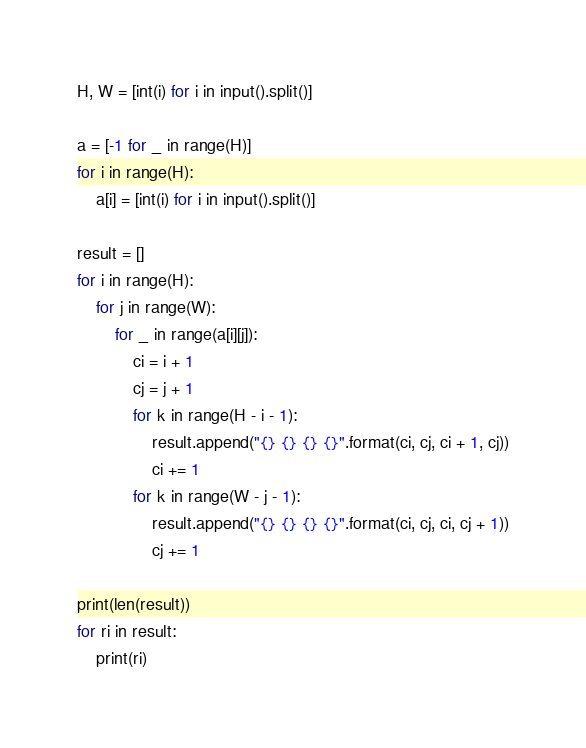<code> <loc_0><loc_0><loc_500><loc_500><_Python_>H, W = [int(i) for i in input().split()]

a = [-1 for _ in range(H)]
for i in range(H):
    a[i] = [int(i) for i in input().split()]

result = []
for i in range(H):
    for j in range(W):
        for _ in range(a[i][j]):
            ci = i + 1
            cj = j + 1
            for k in range(H - i - 1):
                result.append("{} {} {} {}".format(ci, cj, ci + 1, cj))
                ci += 1
            for k in range(W - j - 1):
                result.append("{} {} {} {}".format(ci, cj, ci, cj + 1))
                cj += 1

print(len(result))
for ri in result:
    print(ri)
</code> 